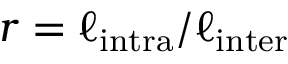<formula> <loc_0><loc_0><loc_500><loc_500>r = \ell _ { i n t r a } / \ell _ { i n t e r }</formula> 